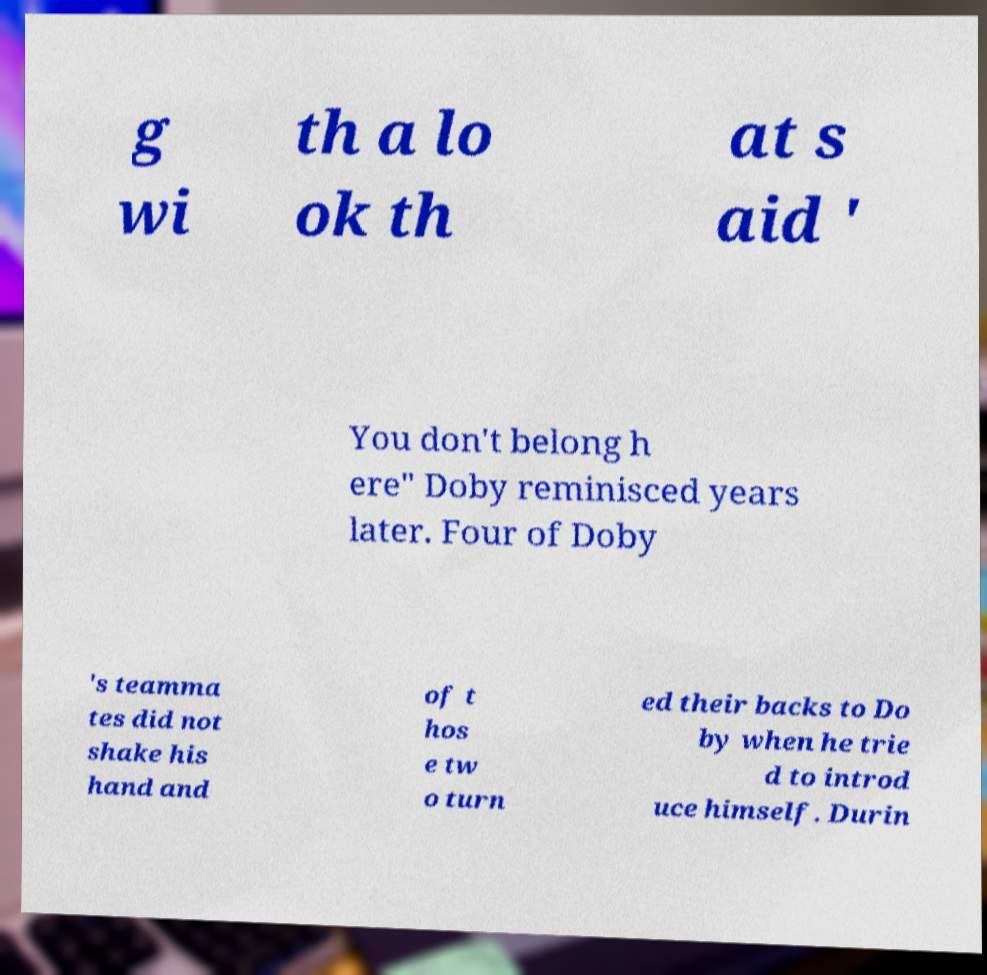Can you read and provide the text displayed in the image?This photo seems to have some interesting text. Can you extract and type it out for me? g wi th a lo ok th at s aid ' You don't belong h ere" Doby reminisced years later. Four of Doby 's teamma tes did not shake his hand and of t hos e tw o turn ed their backs to Do by when he trie d to introd uce himself. Durin 